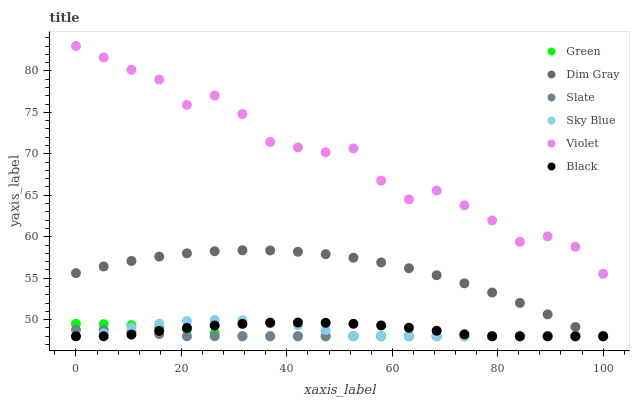Does Slate have the minimum area under the curve?
Answer yes or no. Yes. Does Violet have the maximum area under the curve?
Answer yes or no. Yes. Does Green have the minimum area under the curve?
Answer yes or no. No. Does Green have the maximum area under the curve?
Answer yes or no. No. Is Slate the smoothest?
Answer yes or no. Yes. Is Violet the roughest?
Answer yes or no. Yes. Is Green the smoothest?
Answer yes or no. No. Is Green the roughest?
Answer yes or no. No. Does Dim Gray have the lowest value?
Answer yes or no. Yes. Does Violet have the lowest value?
Answer yes or no. No. Does Violet have the highest value?
Answer yes or no. Yes. Does Green have the highest value?
Answer yes or no. No. Is Dim Gray less than Violet?
Answer yes or no. Yes. Is Violet greater than Black?
Answer yes or no. Yes. Does Dim Gray intersect Green?
Answer yes or no. Yes. Is Dim Gray less than Green?
Answer yes or no. No. Is Dim Gray greater than Green?
Answer yes or no. No. Does Dim Gray intersect Violet?
Answer yes or no. No. 